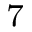Convert formula to latex. <formula><loc_0><loc_0><loc_500><loc_500>_ { 7 }</formula> 